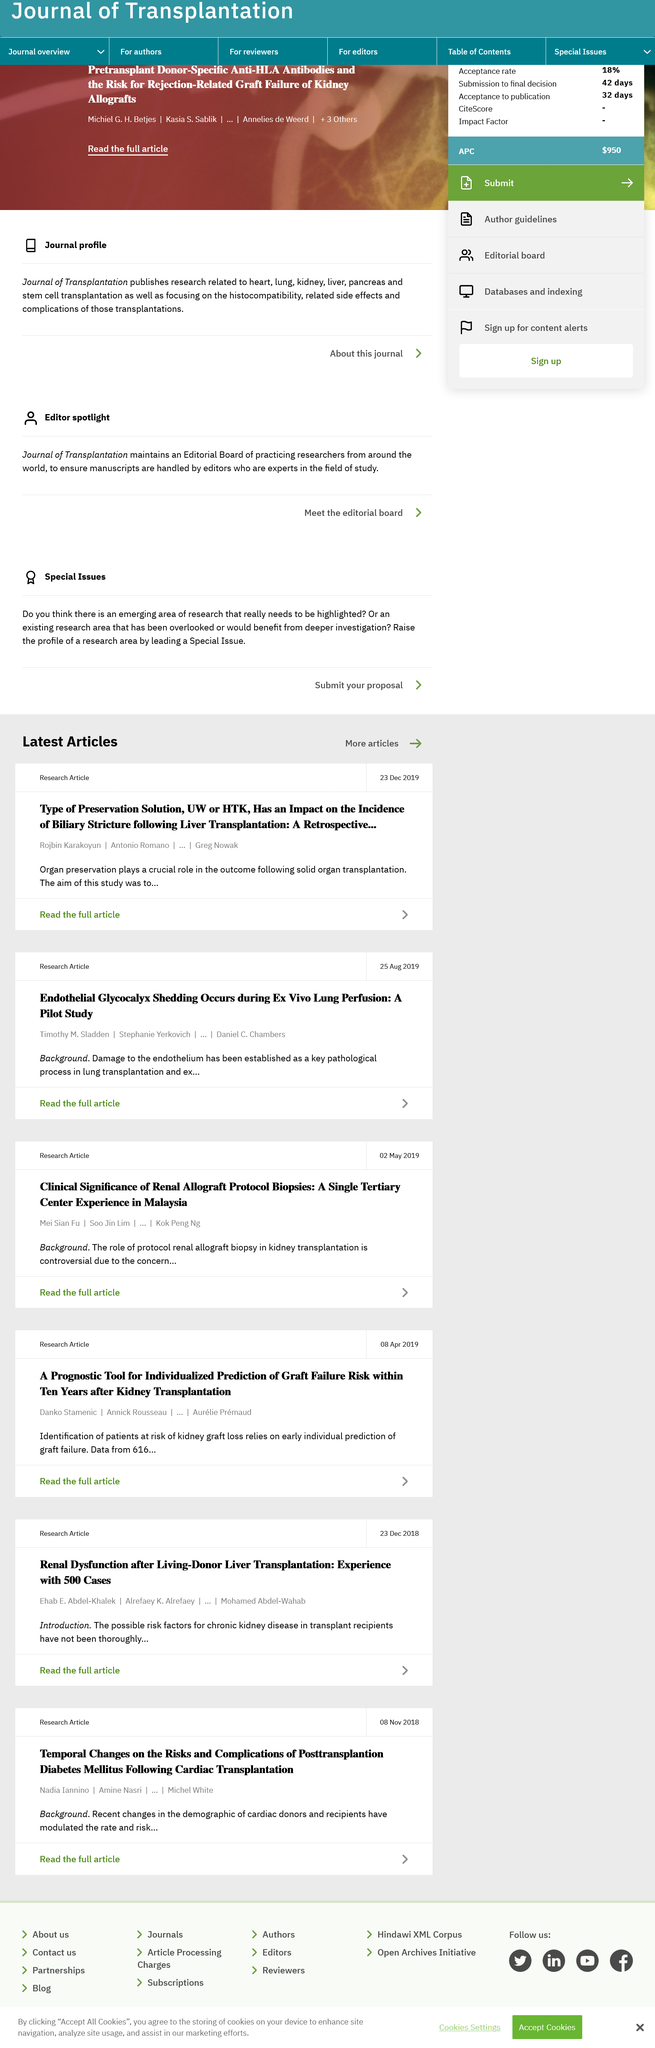List a handful of essential elements in this visual. The article discusses living-donor liver transplants for patients with chronic kidney disease. The article discussing posttransplantation diabetes mellitus was written on November 8, 2018. It is possible to read either a full article or a summary, as full articles are available. 